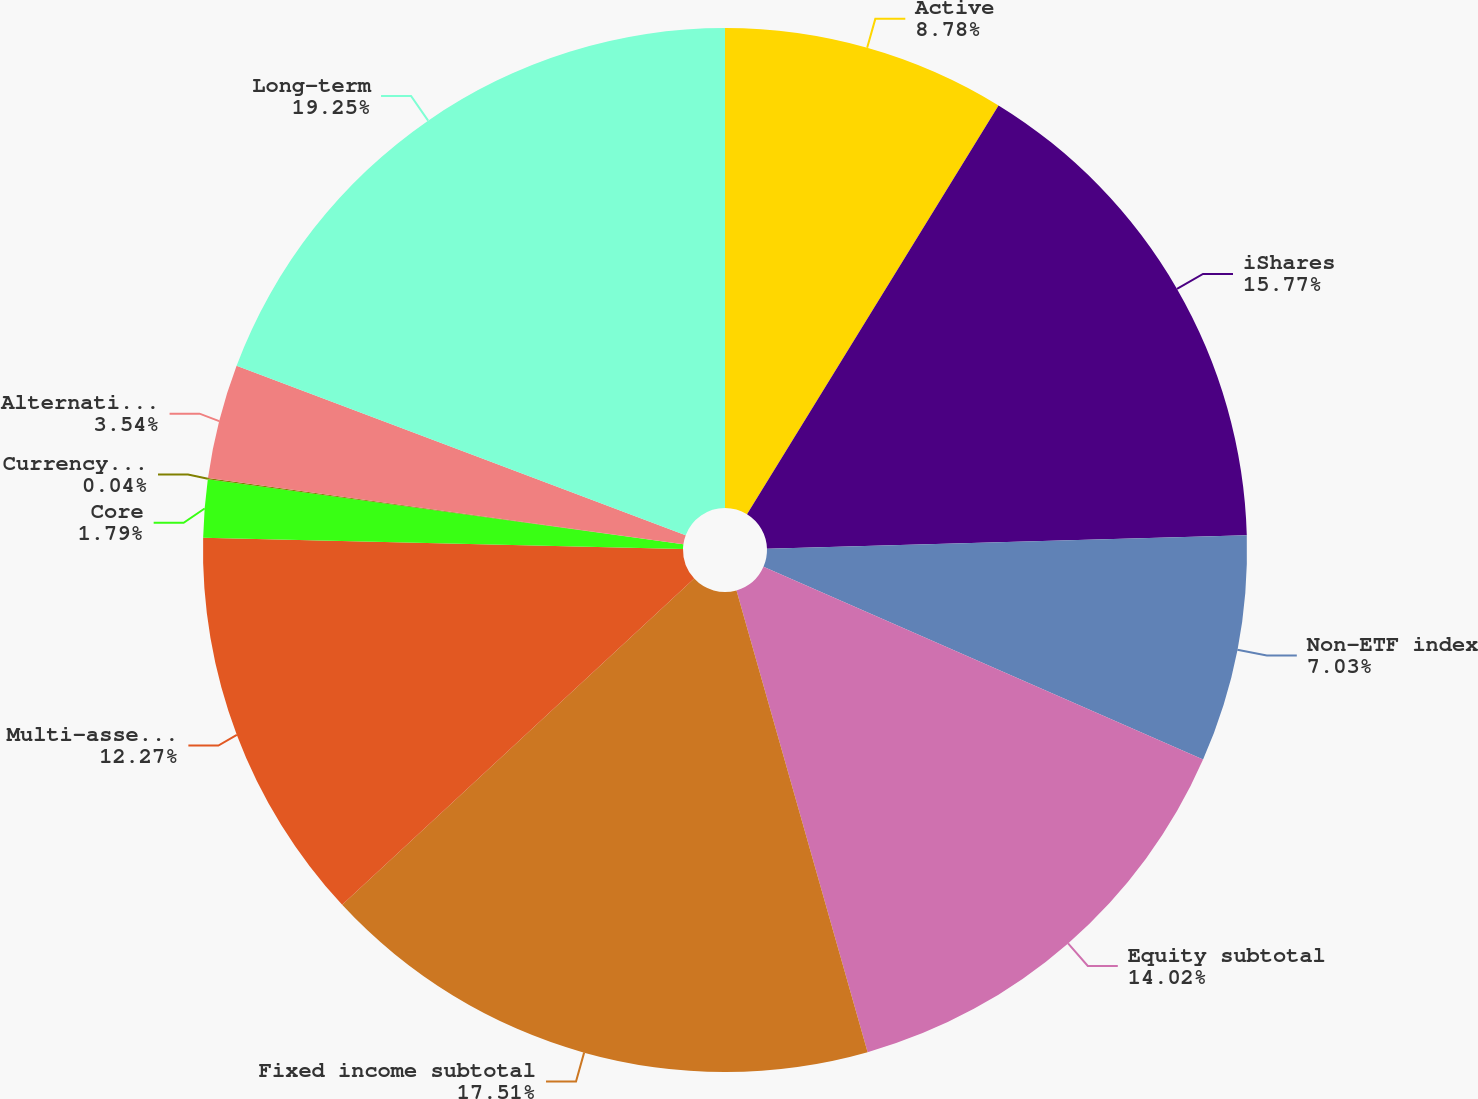Convert chart. <chart><loc_0><loc_0><loc_500><loc_500><pie_chart><fcel>Active<fcel>iShares<fcel>Non-ETF index<fcel>Equity subtotal<fcel>Fixed income subtotal<fcel>Multi-asset class<fcel>Core<fcel>Currency and commodities<fcel>Alternatives subtotal<fcel>Long-term<nl><fcel>8.78%<fcel>15.77%<fcel>7.03%<fcel>14.02%<fcel>17.51%<fcel>12.27%<fcel>1.79%<fcel>0.04%<fcel>3.54%<fcel>19.26%<nl></chart> 